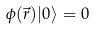<formula> <loc_0><loc_0><loc_500><loc_500>\phi ( \vec { r } ) | 0 \rangle = 0</formula> 